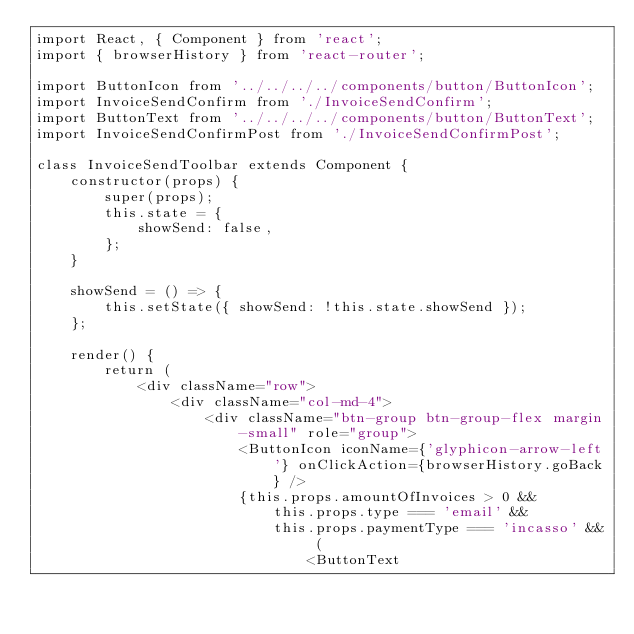Convert code to text. <code><loc_0><loc_0><loc_500><loc_500><_JavaScript_>import React, { Component } from 'react';
import { browserHistory } from 'react-router';

import ButtonIcon from '../../../../components/button/ButtonIcon';
import InvoiceSendConfirm from './InvoiceSendConfirm';
import ButtonText from '../../../../components/button/ButtonText';
import InvoiceSendConfirmPost from './InvoiceSendConfirmPost';

class InvoiceSendToolbar extends Component {
    constructor(props) {
        super(props);
        this.state = {
            showSend: false,
        };
    }

    showSend = () => {
        this.setState({ showSend: !this.state.showSend });
    };

    render() {
        return (
            <div className="row">
                <div className="col-md-4">
                    <div className="btn-group btn-group-flex margin-small" role="group">
                        <ButtonIcon iconName={'glyphicon-arrow-left'} onClickAction={browserHistory.goBack} />
                        {this.props.amountOfInvoices > 0 &&
                            this.props.type === 'email' &&
                            this.props.paymentType === 'incasso' && (
                                <ButtonText</code> 